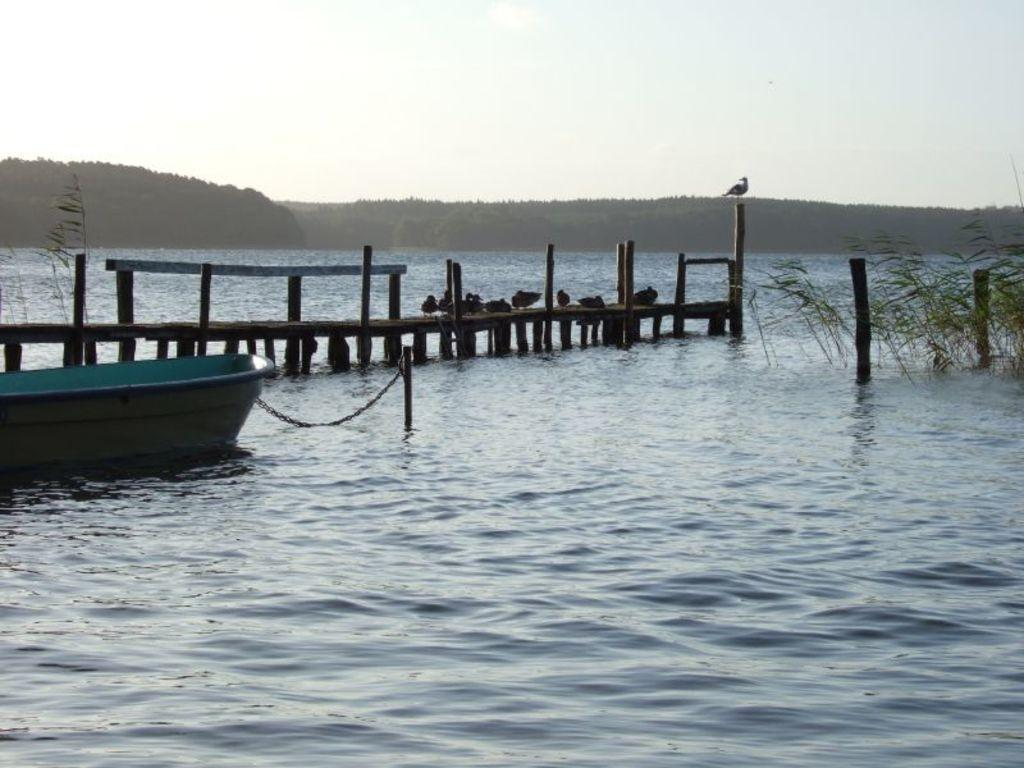What is in the water in the image? There is a boat in the water in the image. What object can be seen connecting the boat to something else? There is a chain in the image connecting the boat to a pole. What type of vegetation is present in the image? There are plants in the image. What is the primary liquid element visible in the image? There is water visible in the image. What geographical feature can be seen in the background of the image? There are mountains in the image. What is the color of the sky in the image? The sky is white in the image. How many birds are visible in the image? There are many birds in the image. What type of butter is being used by the birds in the image? There is no butter present in the image; it features a boat, chain, pole, plants, water, mountains, a white sky, and many birds. What amusement park can be seen in the background of the image? There is no amusement park present in the image; it features a boat, chain, pole, plants, water, mountains, a white sky, and many birds. 